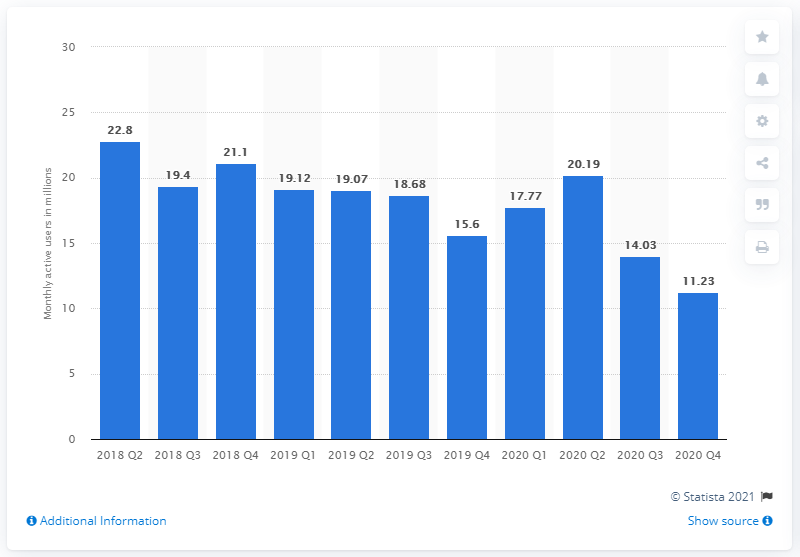Mention a couple of crucial points in this snapshot. In the fourth quarter of 2020, Glu Mobile reported a total of 11.23 monthly active users. 